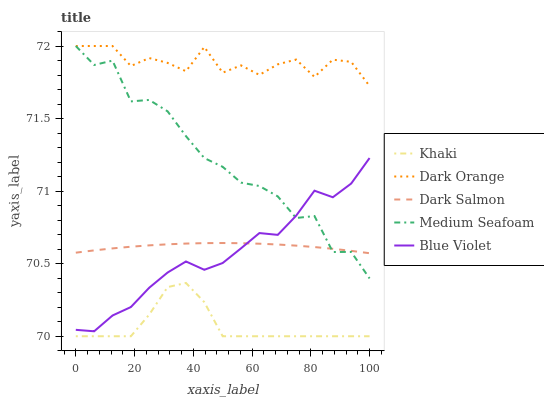Does Dark Salmon have the minimum area under the curve?
Answer yes or no. No. Does Dark Salmon have the maximum area under the curve?
Answer yes or no. No. Is Khaki the smoothest?
Answer yes or no. No. Is Khaki the roughest?
Answer yes or no. No. Does Dark Salmon have the lowest value?
Answer yes or no. No. Does Dark Salmon have the highest value?
Answer yes or no. No. Is Blue Violet less than Dark Orange?
Answer yes or no. Yes. Is Dark Orange greater than Blue Violet?
Answer yes or no. Yes. Does Blue Violet intersect Dark Orange?
Answer yes or no. No. 